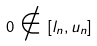<formula> <loc_0><loc_0><loc_500><loc_500>0 \notin [ l _ { n } , u _ { n } ]</formula> 